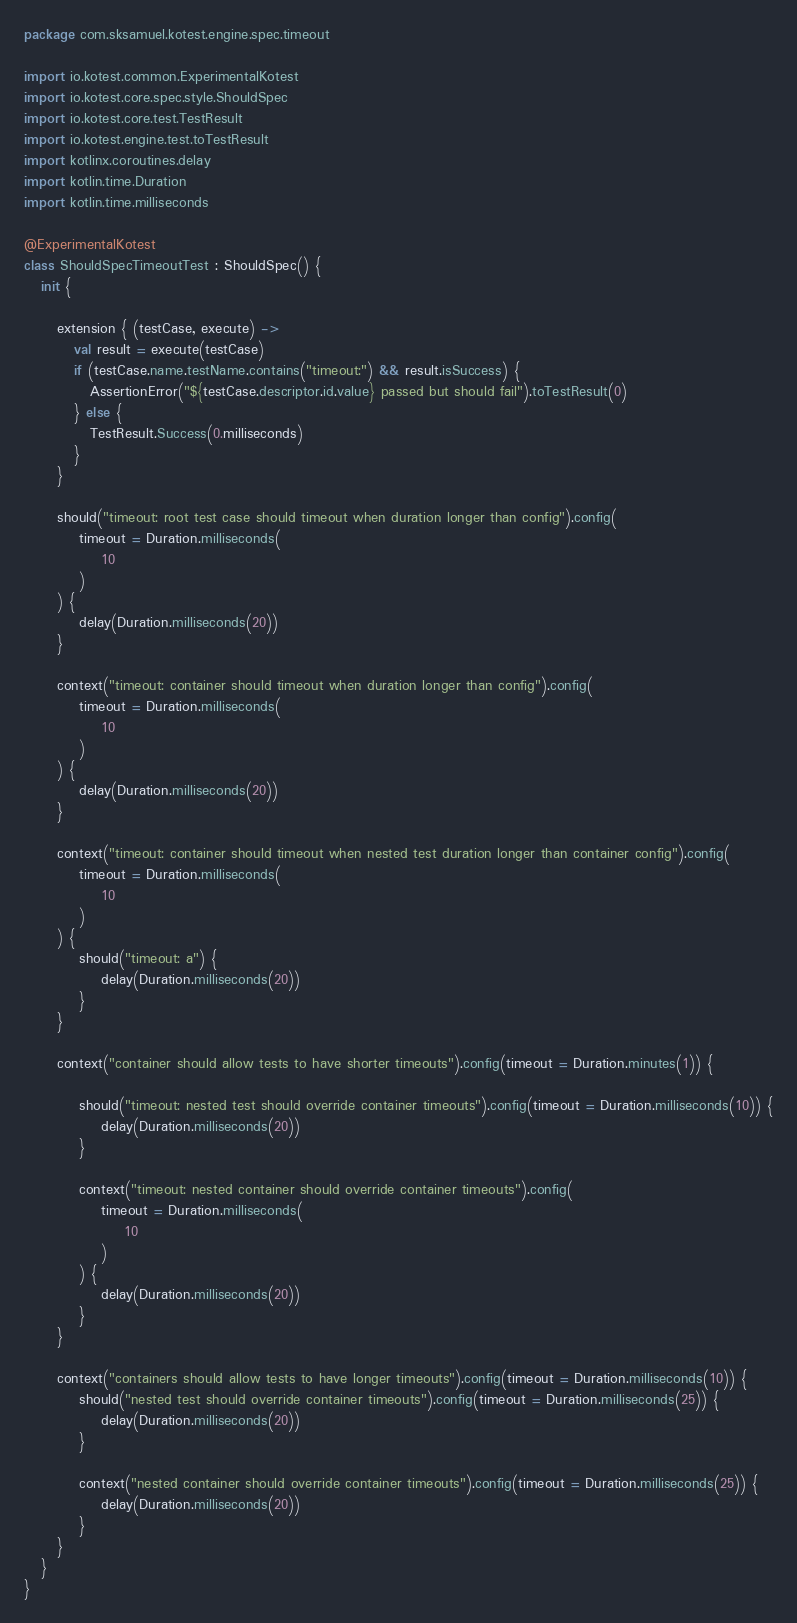Convert code to text. <code><loc_0><loc_0><loc_500><loc_500><_Kotlin_>package com.sksamuel.kotest.engine.spec.timeout

import io.kotest.common.ExperimentalKotest
import io.kotest.core.spec.style.ShouldSpec
import io.kotest.core.test.TestResult
import io.kotest.engine.test.toTestResult
import kotlinx.coroutines.delay
import kotlin.time.Duration
import kotlin.time.milliseconds

@ExperimentalKotest
class ShouldSpecTimeoutTest : ShouldSpec() {
   init {

      extension { (testCase, execute) ->
         val result = execute(testCase)
         if (testCase.name.testName.contains("timeout:") && result.isSuccess) {
            AssertionError("${testCase.descriptor.id.value} passed but should fail").toTestResult(0)
         } else {
            TestResult.Success(0.milliseconds)
         }
      }

      should("timeout: root test case should timeout when duration longer than config").config(
          timeout = Duration.milliseconds(
              10
          )
      ) {
          delay(Duration.milliseconds(20))
      }

      context("timeout: container should timeout when duration longer than config").config(
          timeout = Duration.milliseconds(
              10
          )
      ) {
          delay(Duration.milliseconds(20))
      }

      context("timeout: container should timeout when nested test duration longer than container config").config(
          timeout = Duration.milliseconds(
              10
          )
      ) {
          should("timeout: a") {
              delay(Duration.milliseconds(20))
          }
      }

      context("container should allow tests to have shorter timeouts").config(timeout = Duration.minutes(1)) {

          should("timeout: nested test should override container timeouts").config(timeout = Duration.milliseconds(10)) {
              delay(Duration.milliseconds(20))
          }

          context("timeout: nested container should override container timeouts").config(
              timeout = Duration.milliseconds(
                  10
              )
          ) {
              delay(Duration.milliseconds(20))
          }
      }

      context("containers should allow tests to have longer timeouts").config(timeout = Duration.milliseconds(10)) {
          should("nested test should override container timeouts").config(timeout = Duration.milliseconds(25)) {
              delay(Duration.milliseconds(20))
          }

          context("nested container should override container timeouts").config(timeout = Duration.milliseconds(25)) {
              delay(Duration.milliseconds(20))
          }
      }
   }
}
</code> 